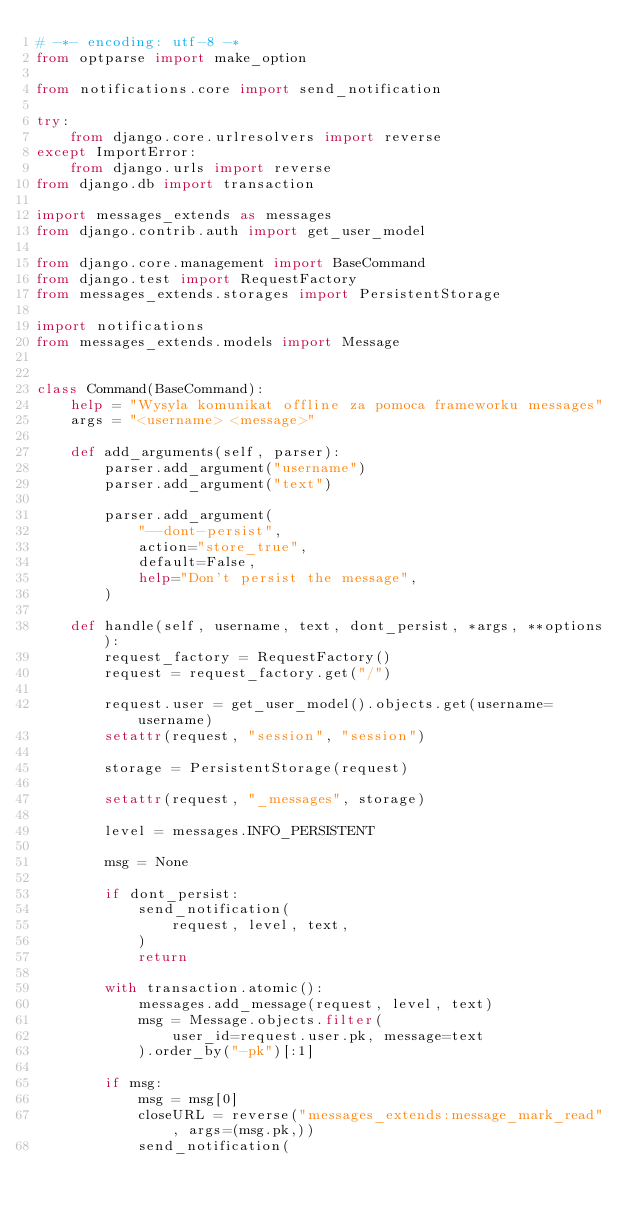Convert code to text. <code><loc_0><loc_0><loc_500><loc_500><_Python_># -*- encoding: utf-8 -*
from optparse import make_option

from notifications.core import send_notification

try:
    from django.core.urlresolvers import reverse
except ImportError:
    from django.urls import reverse
from django.db import transaction

import messages_extends as messages
from django.contrib.auth import get_user_model

from django.core.management import BaseCommand
from django.test import RequestFactory
from messages_extends.storages import PersistentStorage

import notifications
from messages_extends.models import Message


class Command(BaseCommand):
    help = "Wysyla komunikat offline za pomoca frameworku messages"
    args = "<username> <message>"

    def add_arguments(self, parser):
        parser.add_argument("username")
        parser.add_argument("text")

        parser.add_argument(
            "--dont-persist",
            action="store_true",
            default=False,
            help="Don't persist the message",
        )

    def handle(self, username, text, dont_persist, *args, **options):
        request_factory = RequestFactory()
        request = request_factory.get("/")

        request.user = get_user_model().objects.get(username=username)
        setattr(request, "session", "session")

        storage = PersistentStorage(request)

        setattr(request, "_messages", storage)

        level = messages.INFO_PERSISTENT

        msg = None

        if dont_persist:
            send_notification(
                request, level, text,
            )
            return

        with transaction.atomic():
            messages.add_message(request, level, text)
            msg = Message.objects.filter(
                user_id=request.user.pk, message=text
            ).order_by("-pk")[:1]

        if msg:
            msg = msg[0]
            closeURL = reverse("messages_extends:message_mark_read", args=(msg.pk,))
            send_notification(</code> 